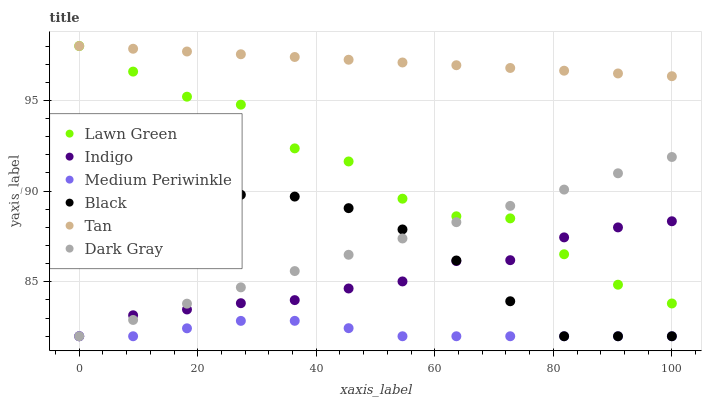Does Medium Periwinkle have the minimum area under the curve?
Answer yes or no. Yes. Does Tan have the maximum area under the curve?
Answer yes or no. Yes. Does Indigo have the minimum area under the curve?
Answer yes or no. No. Does Indigo have the maximum area under the curve?
Answer yes or no. No. Is Tan the smoothest?
Answer yes or no. Yes. Is Lawn Green the roughest?
Answer yes or no. Yes. Is Indigo the smoothest?
Answer yes or no. No. Is Indigo the roughest?
Answer yes or no. No. Does Indigo have the lowest value?
Answer yes or no. Yes. Does Tan have the lowest value?
Answer yes or no. No. Does Tan have the highest value?
Answer yes or no. Yes. Does Indigo have the highest value?
Answer yes or no. No. Is Medium Periwinkle less than Tan?
Answer yes or no. Yes. Is Lawn Green greater than Black?
Answer yes or no. Yes. Does Dark Gray intersect Black?
Answer yes or no. Yes. Is Dark Gray less than Black?
Answer yes or no. No. Is Dark Gray greater than Black?
Answer yes or no. No. Does Medium Periwinkle intersect Tan?
Answer yes or no. No. 